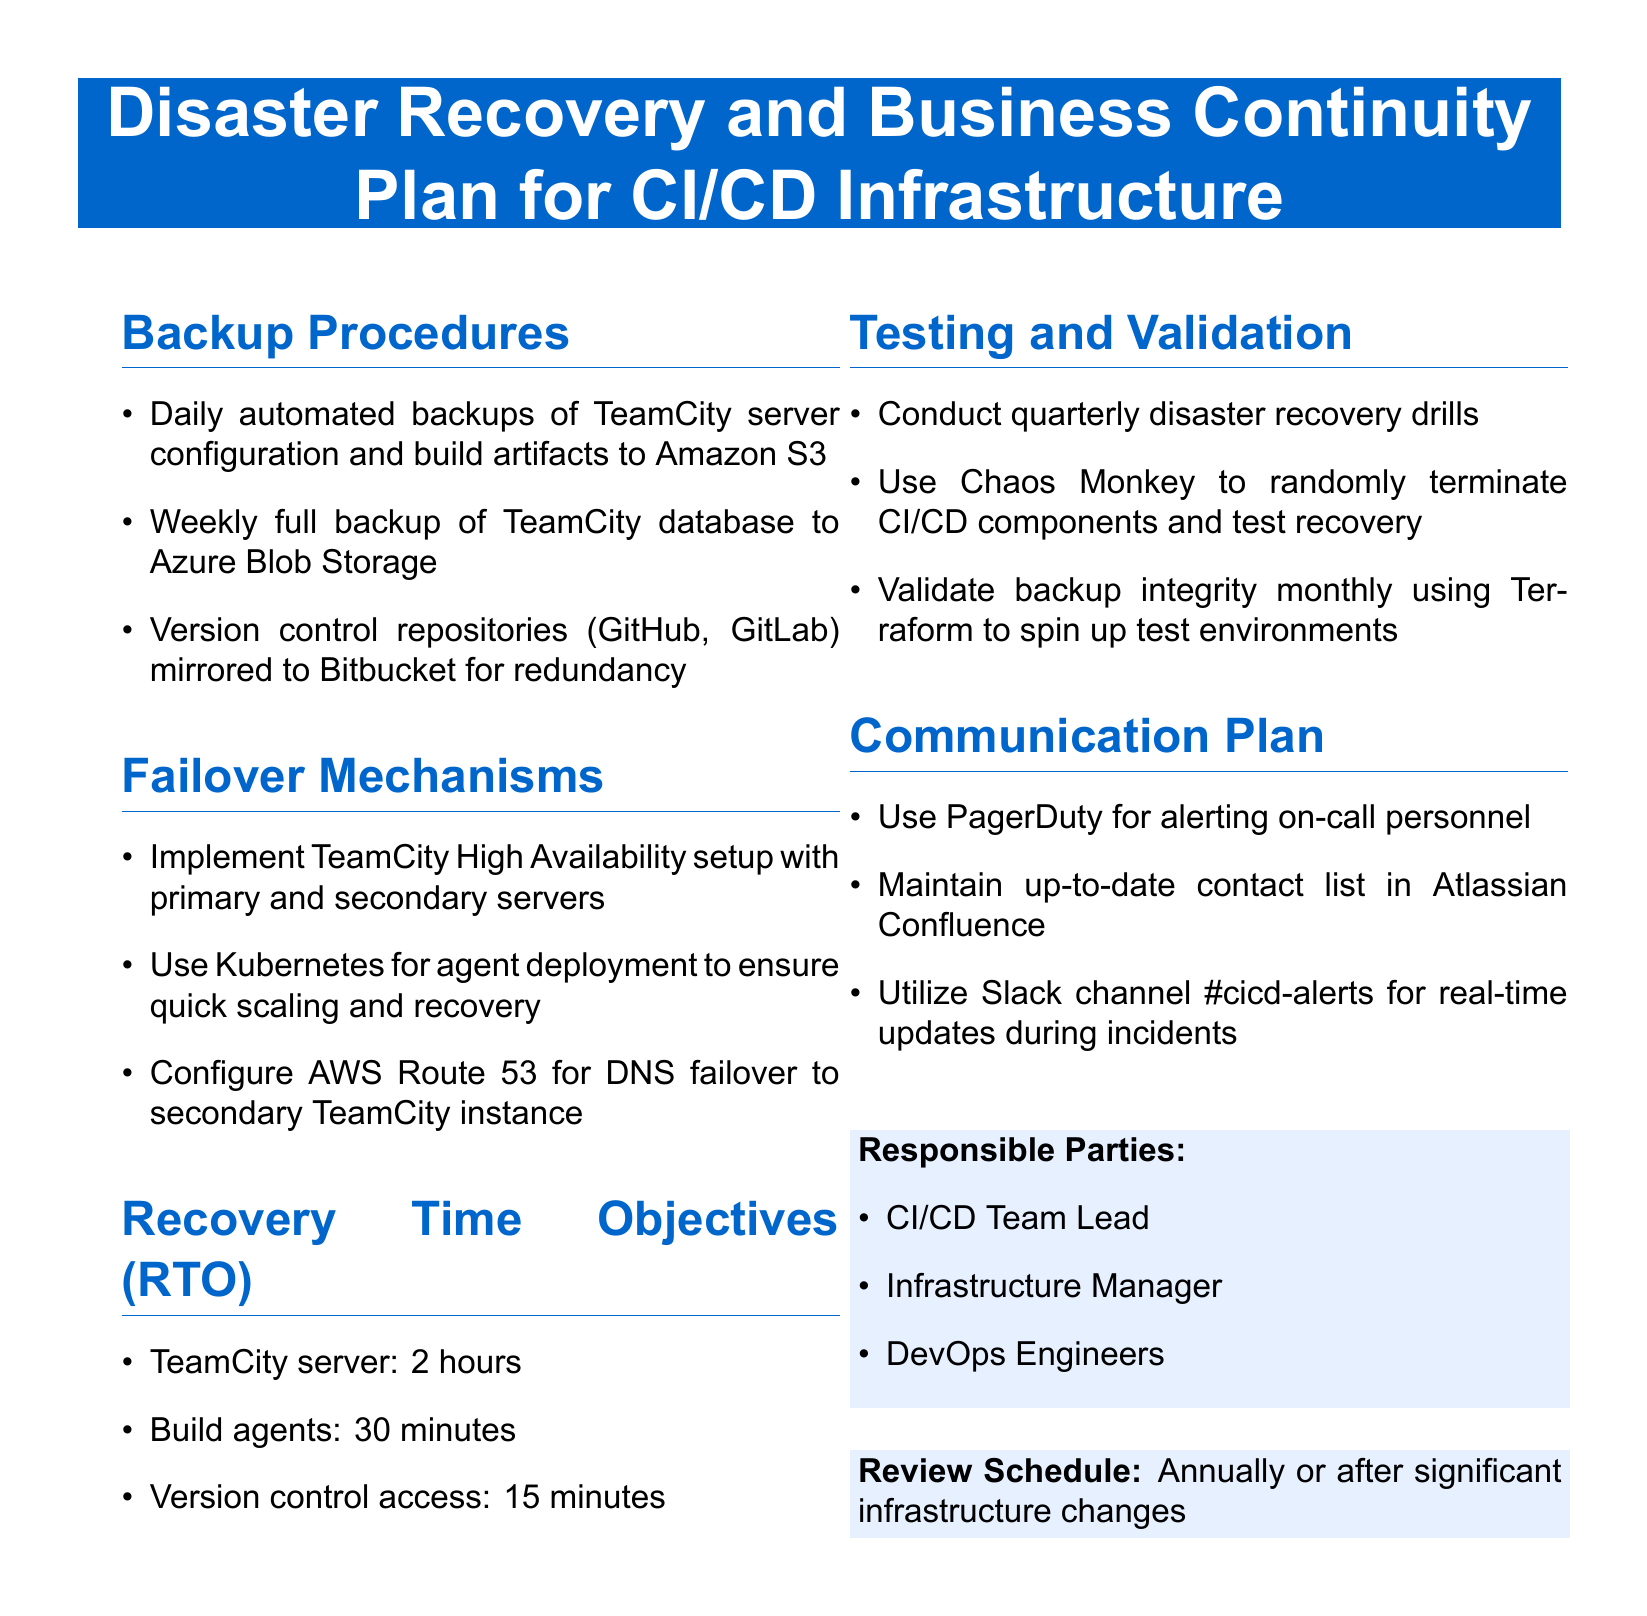What are the daily backup procedures? The daily backup procedures include automated backups of the TeamCity server configuration and build artifacts to Amazon S3.
Answer: Automated backups to Amazon S3 What is the Recovery Time Objective for TeamCity server? The Recovery Time Objective specifies the maximum acceptable time to recover the TeamCity server, which is mentioned in the document.
Answer: 2 hours What tool is used for alerting on-call personnel? The document identifies specific communication tools used during incidents, one of which is crucial for alerting on-call personnel.
Answer: PagerDuty How often are disaster recovery drills conducted? The document outlines the testing and validation methods and their frequency, which is explicitly stated.
Answer: Quarterly What is configured for DNS failover? The failover mechanisms section specifies a particular service that is configured for DNS failover to ensure availability.
Answer: AWS Route 53 Which team members are listed as responsible parties? The document specifies individuals involved in the disaster recovery and business continuity plan, identifying their roles.
Answer: CI/CD Team Lead, Infrastructure Manager, DevOps Engineers What storage service is used for weekly full backups? The weekly full backup section mentions the specific storage service utilized for TeamCity database backups.
Answer: Azure Blob Storage What is the recovery time for build agents? The Recovery Time Objective for build agents indicates the expected time for recovery, which is a specified time in the document.
Answer: 30 minutes 